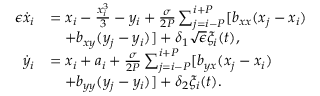Convert formula to latex. <formula><loc_0><loc_0><loc_500><loc_500>\begin{array} { r l } { \epsilon \dot { x } _ { i } } & { = x _ { i } - \frac { x _ { i } ^ { 3 } } { 3 } - y _ { i } + \frac { \sigma } { 2 P } \sum _ { j = i - P } ^ { i + P } [ b _ { x x } ( x _ { j } - x _ { i } ) } \\ & { \quad + b _ { x y } ( y _ { j } - y _ { i } ) ] + \delta _ { 1 } \sqrt { \epsilon } \xi _ { i } ( t ) , } \\ { \dot { y } _ { i } } & { = x _ { i } + a _ { i } + \frac { \sigma } { 2 P } \sum _ { j = i - P } ^ { i + P } [ b _ { y x } ( x _ { j } - x _ { i } ) } \\ & { \quad + b _ { y y } ( y _ { j } - y _ { i } ) ] + \delta _ { 2 } \xi _ { i } ( t ) . } \end{array}</formula> 